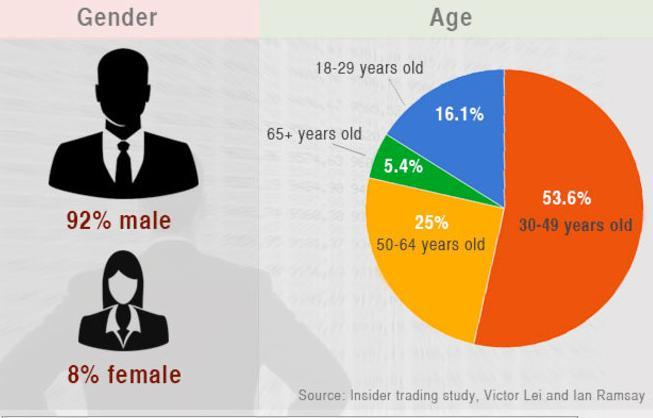What is the percentage of senior citizens in the pie chart?
Answer the question with a short phrase. 5.4% Calculate the total percentage of people aged between 50 and 65+ years? 30.4% What is the total percentage of people aged between 18 and 49 years? 69.7% Which color shows the percentage of people who fall between the age group 50 and 64, blue, green, orange or yellow? yellow Which color shows the percentage of people who are senior citizens  blue, orange, or green? green Calculate the total percentage of people aged between 18 and 65+ years? 100.1% What is total percentage of people falling into both gender ? 100% What is the total percentage of people that fall between the age group 18 and 64 years? 94.7% Which color shows the percentage of people falling under the age group 18 and 29 years, green, blue, or yellow? blue What is the total percentage of people aged between 30 to 64 years? 78.6% 